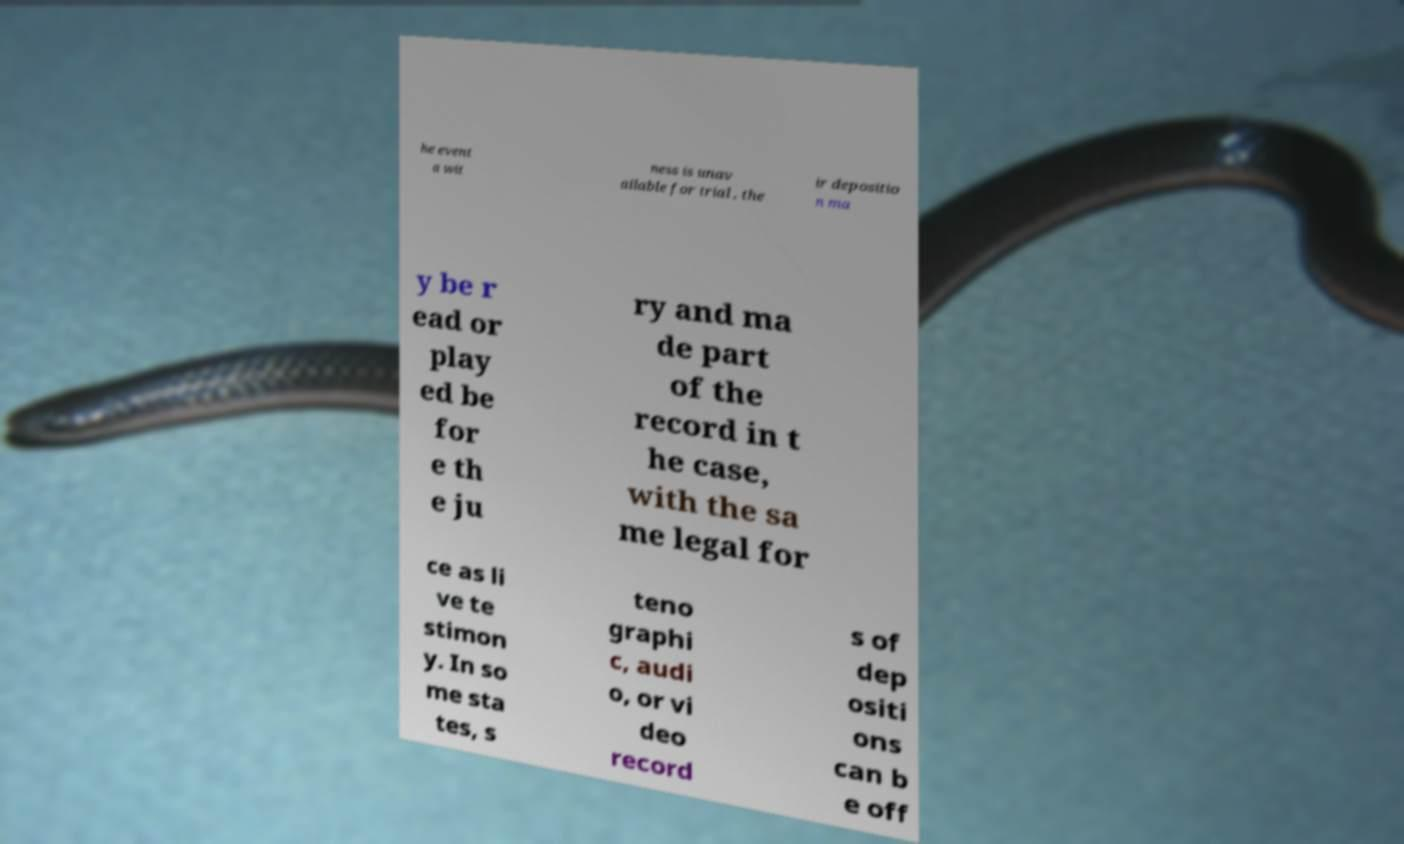Can you read and provide the text displayed in the image?This photo seems to have some interesting text. Can you extract and type it out for me? he event a wit ness is unav ailable for trial , the ir depositio n ma y be r ead or play ed be for e th e ju ry and ma de part of the record in t he case, with the sa me legal for ce as li ve te stimon y. In so me sta tes, s teno graphi c, audi o, or vi deo record s of dep ositi ons can b e off 